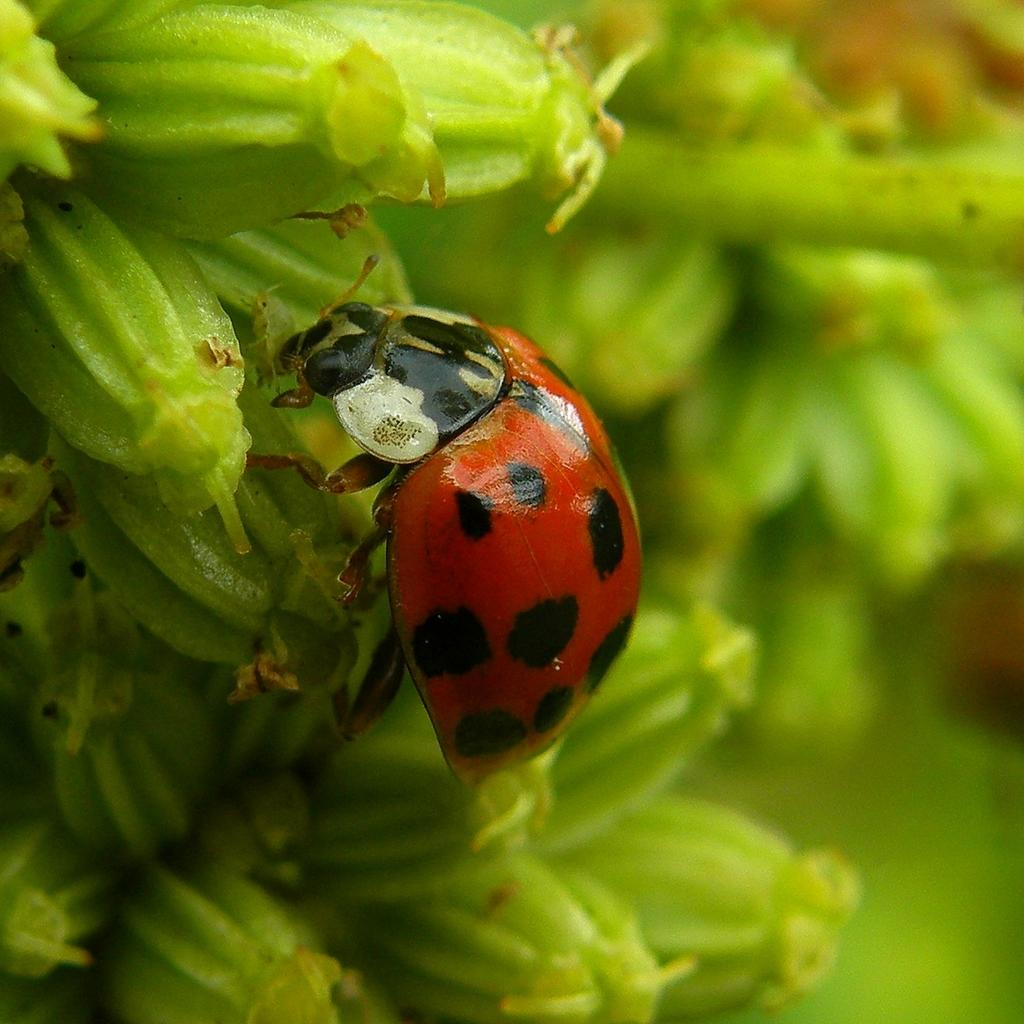What is the main subject of the image? The main subject of the image is a macro photography of an insect. What color is the background of the image? The background of the image is green in color. How is the background of the image depicted? The background of the image is blurred. Reasoning: Let'ing: Let's think step by step in order to produce the conversation. We start by identifying the main subject of the image, which is the macro photography of an insect. Then, we describe the background of the image, mentioning its color and the fact that it is blurred. Each question is designed to elicit a specific detail about the image that is known from the provided facts. Absurd Question/Answer: What type of coat is the insect wearing in the image? There is no coat present on the insect in the image, as insects do not wear clothing. 